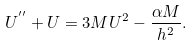Convert formula to latex. <formula><loc_0><loc_0><loc_500><loc_500>U ^ { ^ { \prime \prime } } + U = 3 M U ^ { 2 } - \frac { \alpha M } { h ^ { 2 } } .</formula> 